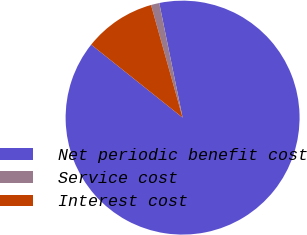Convert chart. <chart><loc_0><loc_0><loc_500><loc_500><pie_chart><fcel>Net periodic benefit cost<fcel>Service cost<fcel>Interest cost<nl><fcel>88.92%<fcel>1.15%<fcel>9.93%<nl></chart> 